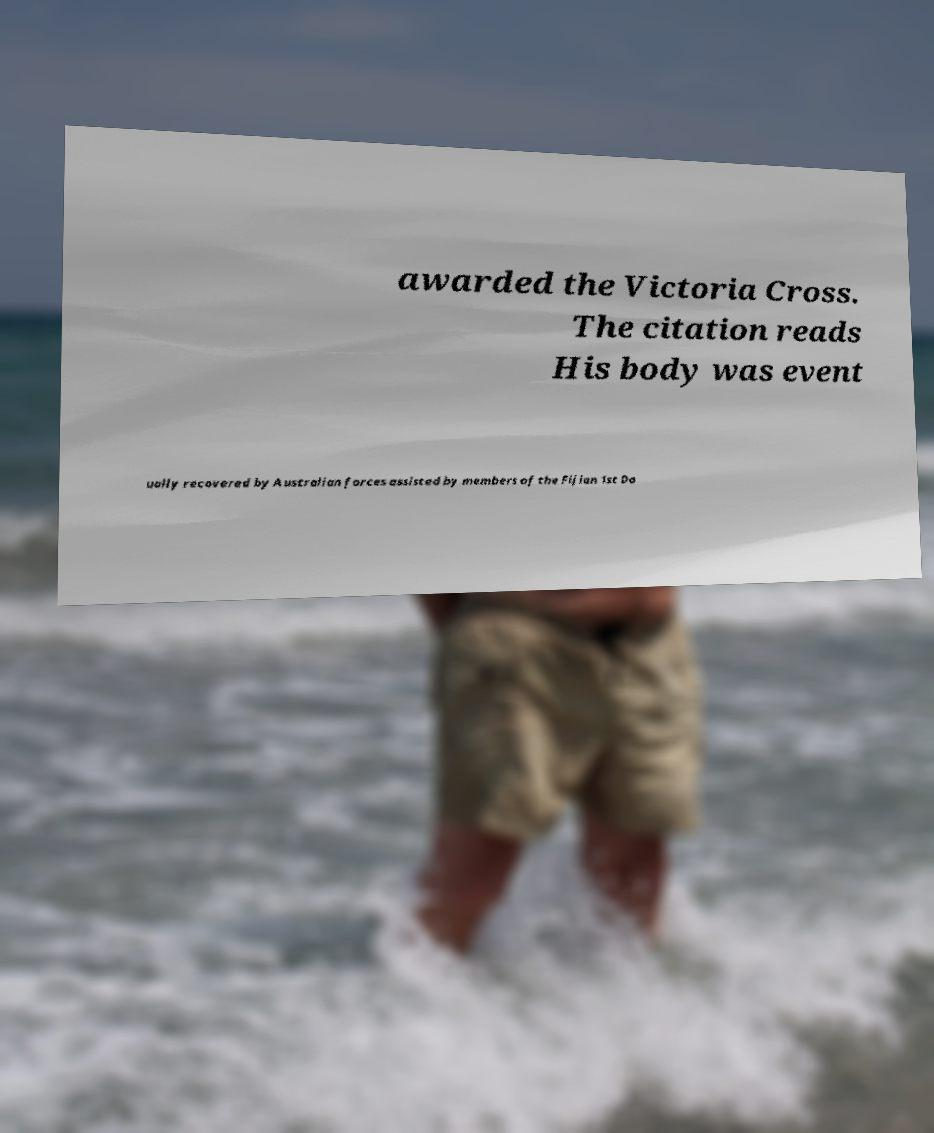Could you assist in decoding the text presented in this image and type it out clearly? awarded the Victoria Cross. The citation reads His body was event ually recovered by Australian forces assisted by members of the Fijian 1st Do 